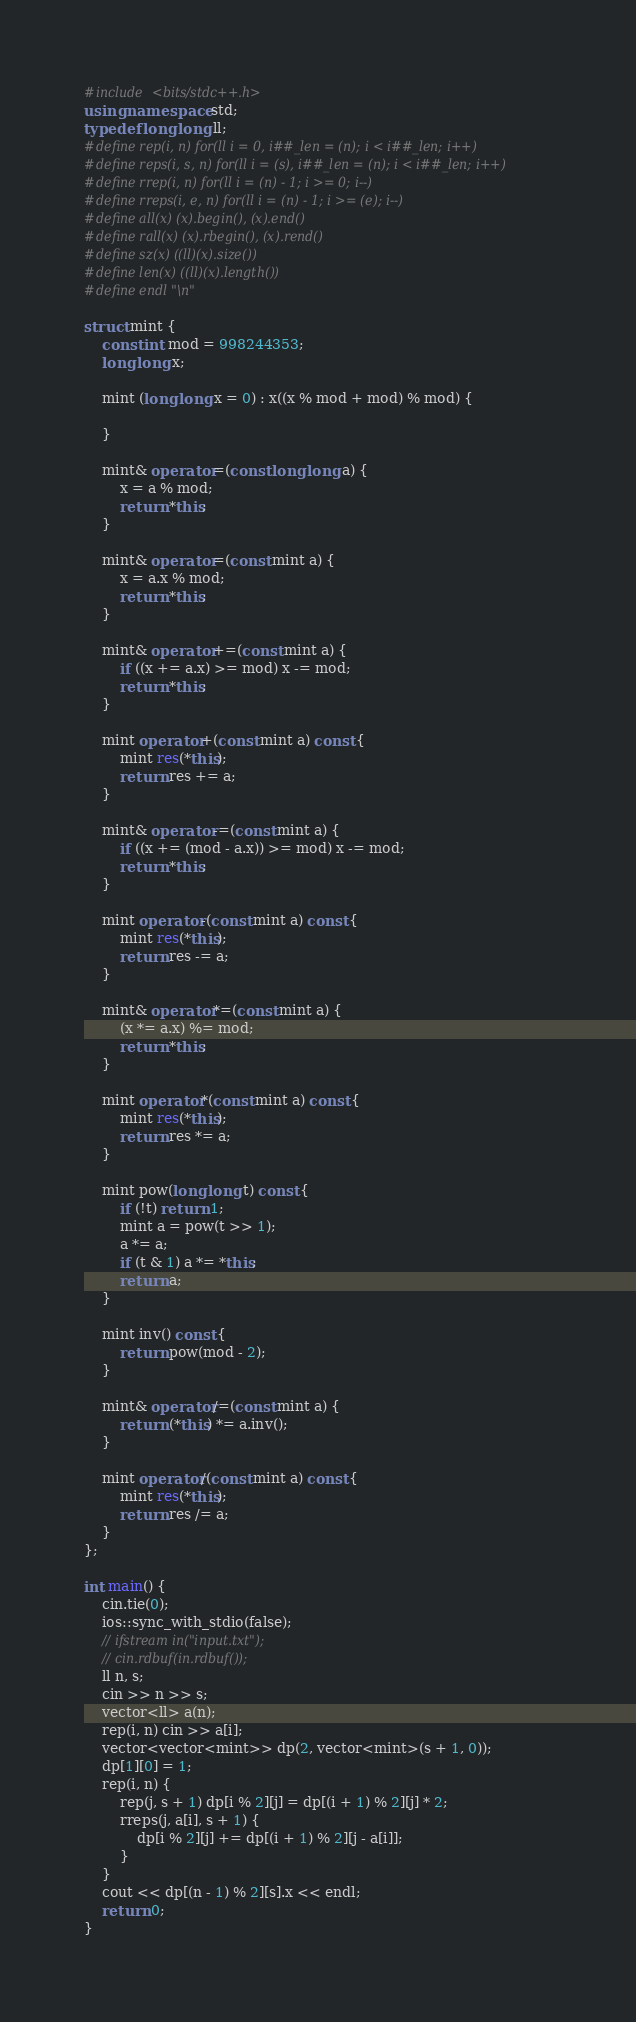Convert code to text. <code><loc_0><loc_0><loc_500><loc_500><_C++_>#include <bits/stdc++.h>
using namespace std;
typedef long long ll;
#define rep(i, n) for(ll i = 0, i##_len = (n); i < i##_len; i++)
#define reps(i, s, n) for(ll i = (s), i##_len = (n); i < i##_len; i++)
#define rrep(i, n) for(ll i = (n) - 1; i >= 0; i--)
#define rreps(i, e, n) for(ll i = (n) - 1; i >= (e); i--)
#define all(x) (x).begin(), (x).end()
#define rall(x) (x).rbegin(), (x).rend()
#define sz(x) ((ll)(x).size())
#define len(x) ((ll)(x).length())
#define endl "\n"

struct mint {
    const int mod = 998244353;
    long long x;
    
    mint (long long x = 0) : x((x % mod + mod) % mod) {
        
    }
    
    mint& operator=(const long long a) {
        x = a % mod;
        return *this;
    }
    
    mint& operator=(const mint a) {
        x = a.x % mod;
        return *this;
    }
    
    mint& operator+=(const mint a) {
        if ((x += a.x) >= mod) x -= mod;
        return *this;
    }
    
    mint operator+(const mint a) const {
        mint res(*this);
        return res += a;
    }
    
    mint& operator-=(const mint a) {
        if ((x += (mod - a.x)) >= mod) x -= mod;
        return *this;
    }
    
    mint operator-(const mint a) const {
        mint res(*this);
        return res -= a;
    }
    
    mint& operator*=(const mint a) {
        (x *= a.x) %= mod;
        return *this;
    }
    
    mint operator*(const mint a) const {
        mint res(*this);
        return res *= a;
    }
    
    mint pow(long long t) const {
        if (!t) return 1;
        mint a = pow(t >> 1);
        a *= a;
        if (t & 1) a *= *this;
        return a;
    }
    
    mint inv() const {
        return pow(mod - 2);
    }
    
    mint& operator/=(const mint a) {
        return (*this) *= a.inv();
    }
    
    mint operator/(const mint a) const {
        mint res(*this);
        return res /= a;
    }
};

int main() {
    cin.tie(0);
    ios::sync_with_stdio(false);
    // ifstream in("input.txt");
    // cin.rdbuf(in.rdbuf());
    ll n, s;
    cin >> n >> s;
    vector<ll> a(n);
    rep(i, n) cin >> a[i];
    vector<vector<mint>> dp(2, vector<mint>(s + 1, 0));
    dp[1][0] = 1;
    rep(i, n) {
        rep(j, s + 1) dp[i % 2][j] = dp[(i + 1) % 2][j] * 2;
        rreps(j, a[i], s + 1) {
            dp[i % 2][j] += dp[(i + 1) % 2][j - a[i]];
        }
    }
    cout << dp[(n - 1) % 2][s].x << endl;
    return 0;
}
</code> 